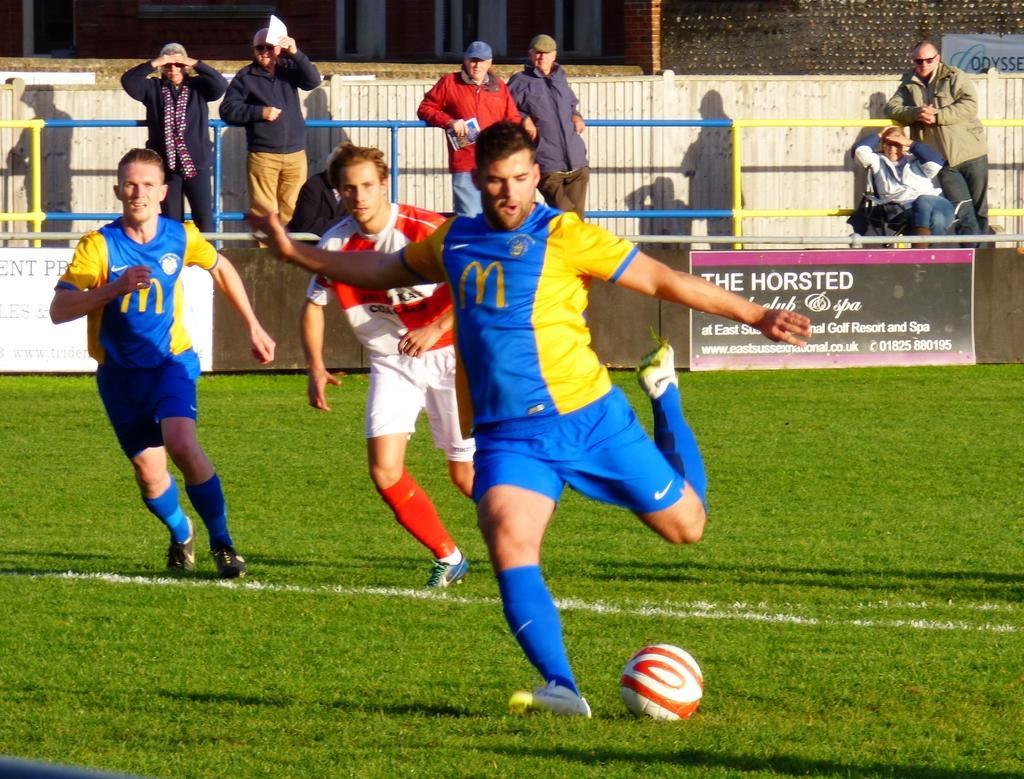Could you give a brief overview of what you see in this image? In this picture is there are three men running and there is a ball on the floor there are some people standing behind and watching them 